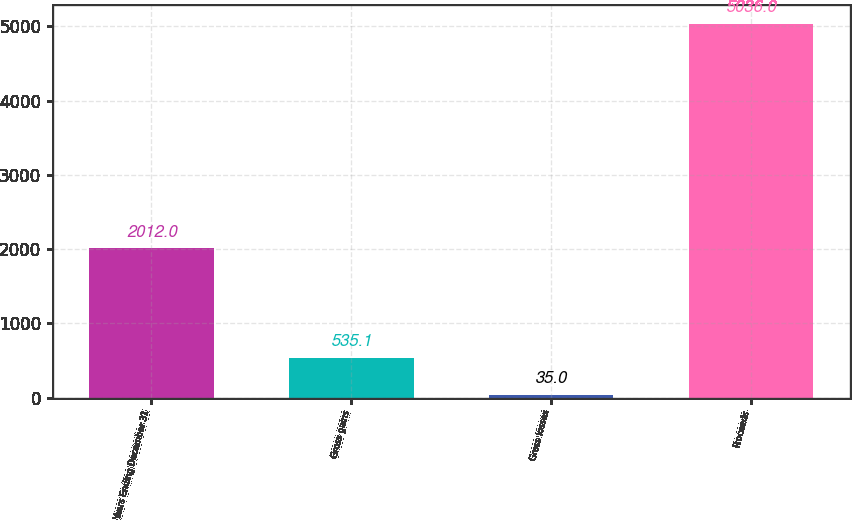Convert chart to OTSL. <chart><loc_0><loc_0><loc_500><loc_500><bar_chart><fcel>Years Ending December 31<fcel>Gross gains<fcel>Gross losses<fcel>Proceeds<nl><fcel>2012<fcel>535.1<fcel>35<fcel>5036<nl></chart> 